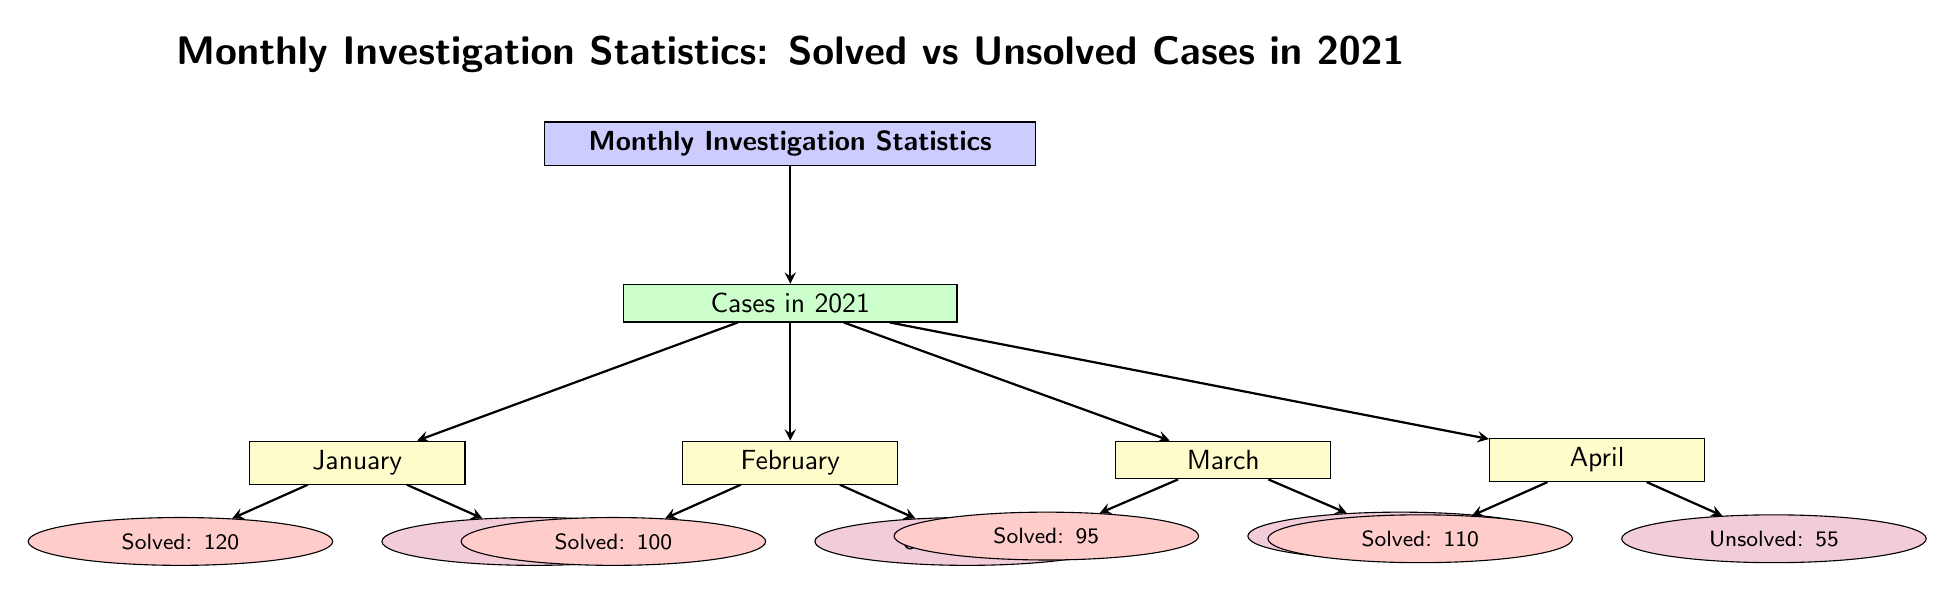What is the total number of solved cases in January? The diagram specifies that January has 120 solved cases listed under the "Solved" node for that month.
Answer: 120 What is the number of unsolved cases in February? The diagram shows that February has 60 unsolved cases indicated by the "Unsolved" node for that month.
Answer: 60 How many total cases (solved + unsolved) were there in March? For March, there are 95 solved cases and 70 unsolved cases. Adding these gives a total of 95 + 70 = 165.
Answer: 165 Which month had the highest number of solved cases? By comparing the solved cases for each month, January (120) has the highest number compared to February (100), March (95), and April (110).
Answer: January What is the difference between solved and unsolved cases in April? In April, there are 110 solved cases and 55 unsolved cases. The difference is calculated as 110 - 55 = 55.
Answer: 55 What is the total number of unsolved cases across all listed months? Summing the unsolved cases for each month: 45 (January) + 60 (February) + 70 (March) + 55 (April) results in a total of 230 unsolved cases.
Answer: 230 Which month has the lowest total number of cases (solved + unsolved)? February has 100 solved cases and 60 unsolved cases, totaling 160 cases. Comparatively, January (165), March (165), and April (165) have more. Therefore, February is the month with the lowest total cases.
Answer: February What was the average number of solved cases per month? The total solved cases across the four months are 120 (January) + 100 (February) + 95 (March) + 110 (April) = 425. Dividing by 4 (number of months), the average is 425 / 4 = 106.25, but rounding down gives 106.
Answer: 106 Which month had the lowest number of solved cases? From the diagram, March has the lowest number of solved cases at 95 compared to January (120), February (100), and April (110).
Answer: March 